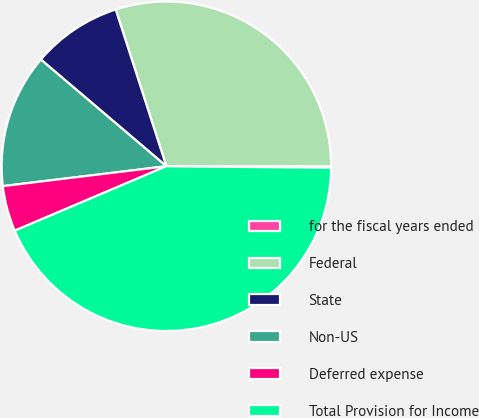Convert chart. <chart><loc_0><loc_0><loc_500><loc_500><pie_chart><fcel>for the fiscal years ended<fcel>Federal<fcel>State<fcel>Non-US<fcel>Deferred expense<fcel>Total Provision for Income<nl><fcel>0.14%<fcel>29.98%<fcel>8.81%<fcel>13.14%<fcel>4.47%<fcel>43.46%<nl></chart> 